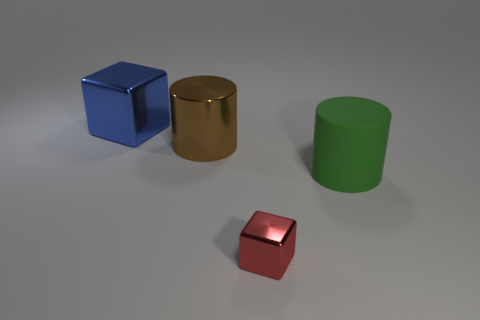How many big things are shiny things or blue shiny blocks?
Provide a short and direct response. 2. There is a matte thing; is it the same size as the metallic cube that is to the left of the large brown shiny cylinder?
Provide a short and direct response. Yes. What number of other objects are there of the same shape as the brown shiny object?
Your response must be concise. 1. There is a large blue object that is the same material as the large brown object; what shape is it?
Offer a terse response. Cube. Are there any metallic cylinders?
Keep it short and to the point. Yes. Is the number of tiny objects that are behind the big blue block less than the number of large green cylinders that are in front of the green thing?
Keep it short and to the point. No. The object in front of the green object has what shape?
Your answer should be compact. Cube. Is the large blue thing made of the same material as the big brown cylinder?
Provide a succinct answer. Yes. Is there any other thing that is the same material as the tiny red block?
Keep it short and to the point. Yes. What is the material of the other object that is the same shape as the red metal thing?
Offer a very short reply. Metal. 